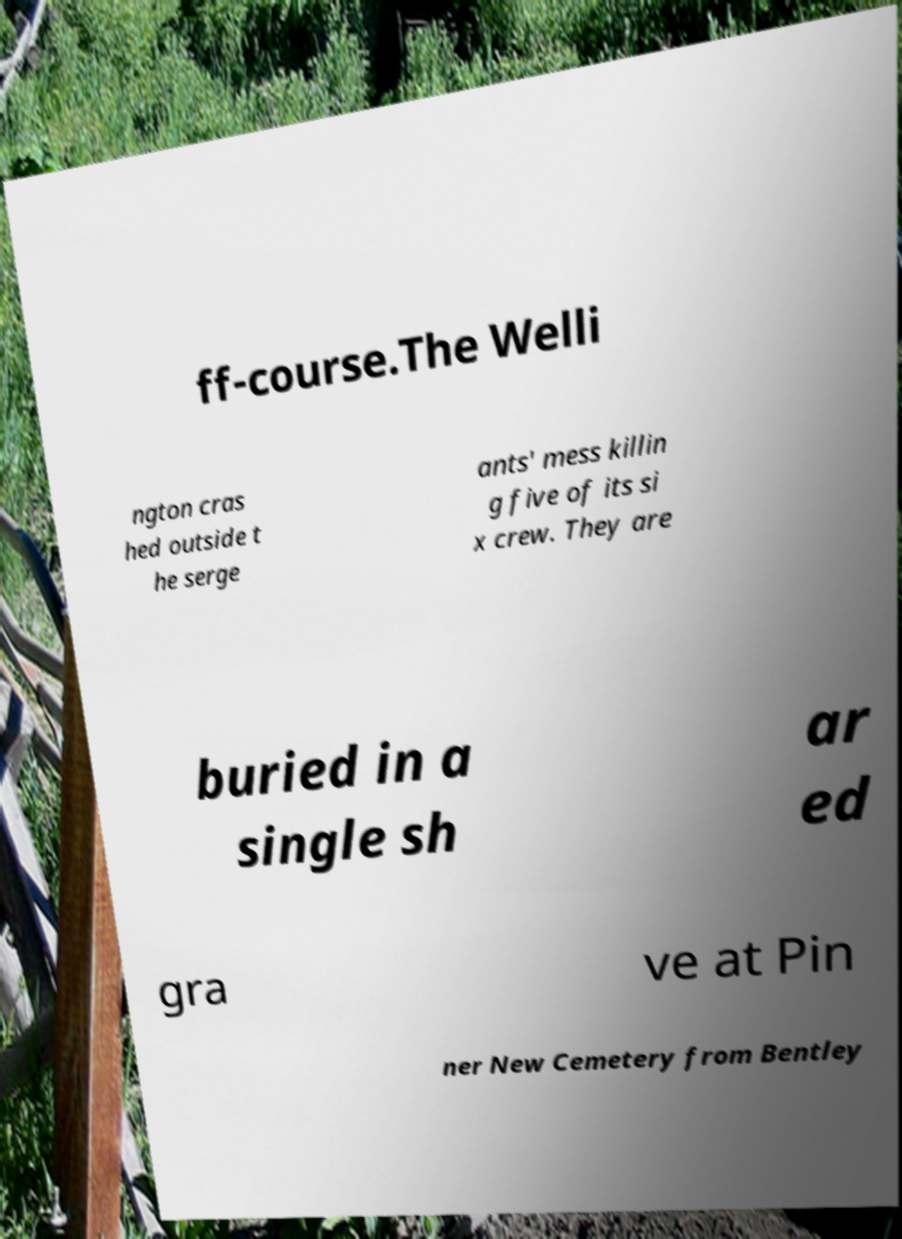Could you extract and type out the text from this image? ff-course.The Welli ngton cras hed outside t he serge ants' mess killin g five of its si x crew. They are buried in a single sh ar ed gra ve at Pin ner New Cemetery from Bentley 